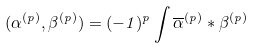<formula> <loc_0><loc_0><loc_500><loc_500>( \alpha ^ { ( p ) } , \beta ^ { ( p ) } ) = ( - 1 ) ^ { p } \int \overline { \alpha } ^ { ( p ) } * \beta ^ { ( p ) }</formula> 